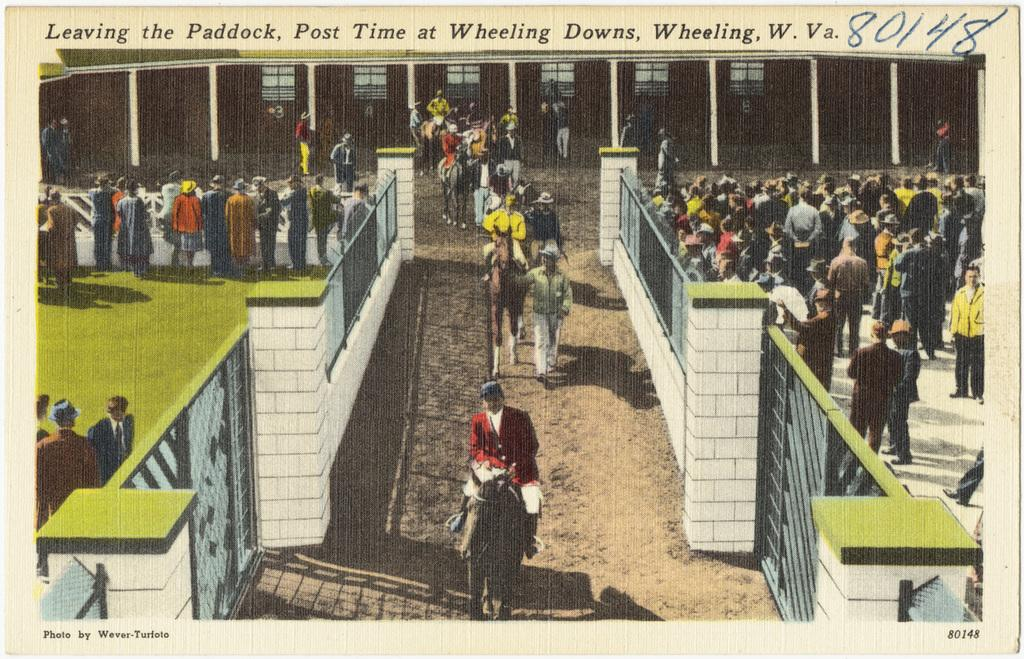<image>
Share a concise interpretation of the image provided. A postcard that reads Leaving the Paddock, Post Time at Wheeling Dons, Wheeling, W. Va 